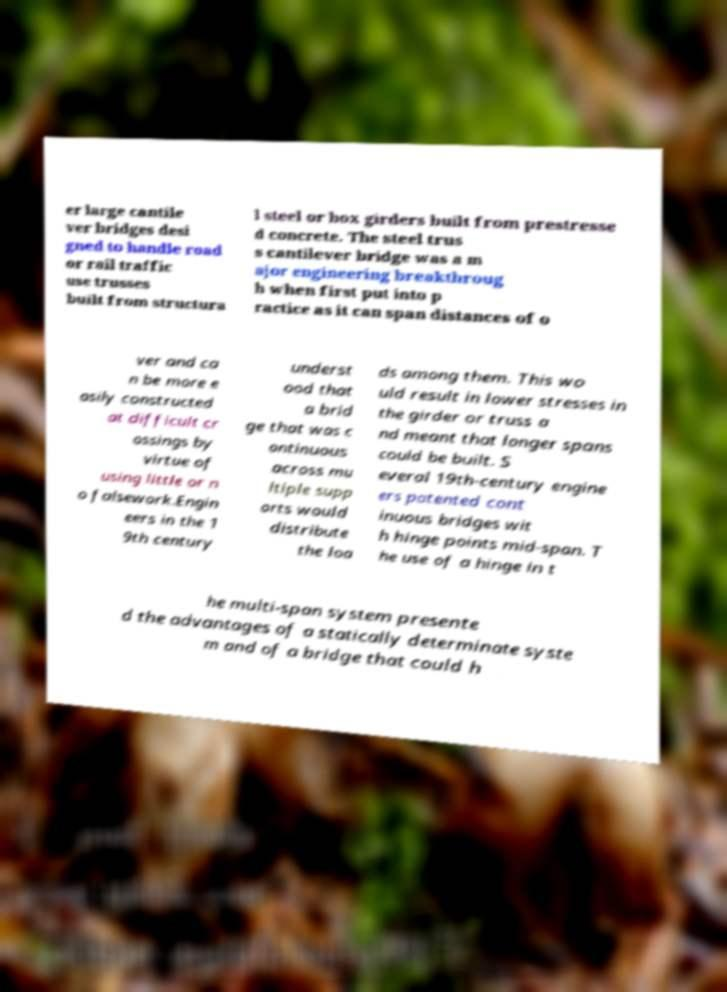Please identify and transcribe the text found in this image. er large cantile ver bridges desi gned to handle road or rail traffic use trusses built from structura l steel or box girders built from prestresse d concrete. The steel trus s cantilever bridge was a m ajor engineering breakthroug h when first put into p ractice as it can span distances of o ver and ca n be more e asily constructed at difficult cr ossings by virtue of using little or n o falsework.Engin eers in the 1 9th century underst ood that a brid ge that was c ontinuous across mu ltiple supp orts would distribute the loa ds among them. This wo uld result in lower stresses in the girder or truss a nd meant that longer spans could be built. S everal 19th-century engine ers patented cont inuous bridges wit h hinge points mid-span. T he use of a hinge in t he multi-span system presente d the advantages of a statically determinate syste m and of a bridge that could h 